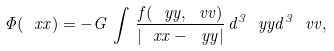<formula> <loc_0><loc_0><loc_500><loc_500>\Phi ( \ x x ) = - G \, \int \, \frac { f ( \ y y , \ v v ) } { | \ x x - \ y y | } \, d ^ { 3 } \ y y d ^ { 3 } \ v v ,</formula> 